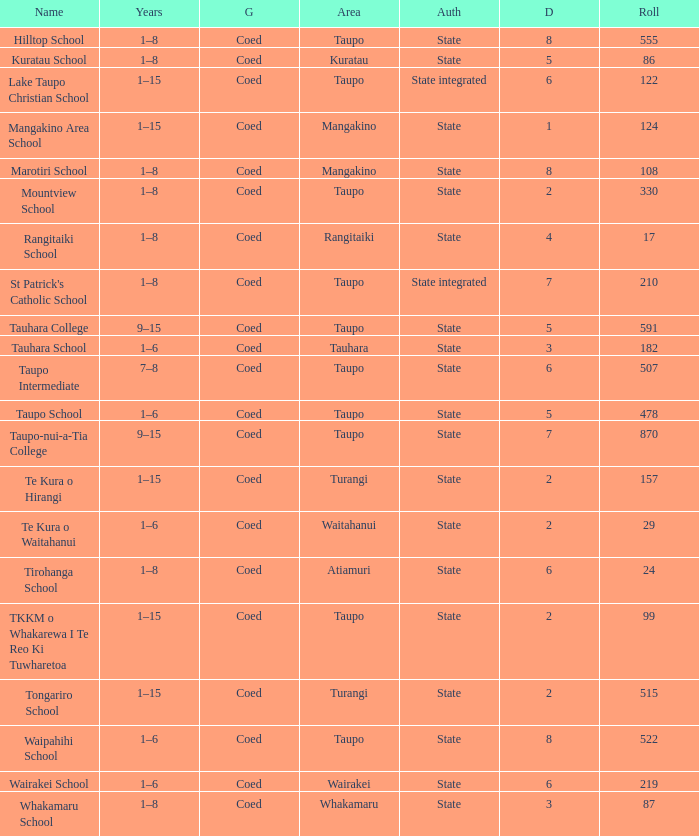What is the Whakamaru school's authority? State. 